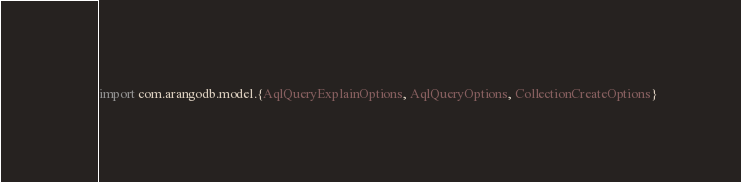Convert code to text. <code><loc_0><loc_0><loc_500><loc_500><_Scala_>import com.arangodb.model.{AqlQueryExplainOptions, AqlQueryOptions, CollectionCreateOptions}</code> 